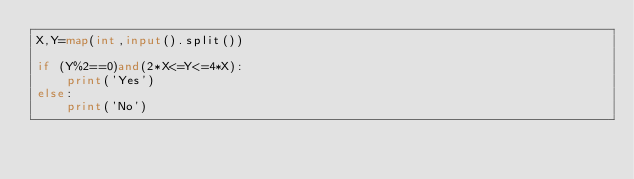<code> <loc_0><loc_0><loc_500><loc_500><_Python_>X,Y=map(int,input().split())

if (Y%2==0)and(2*X<=Y<=4*X):
    print('Yes')
else:
    print('No')</code> 